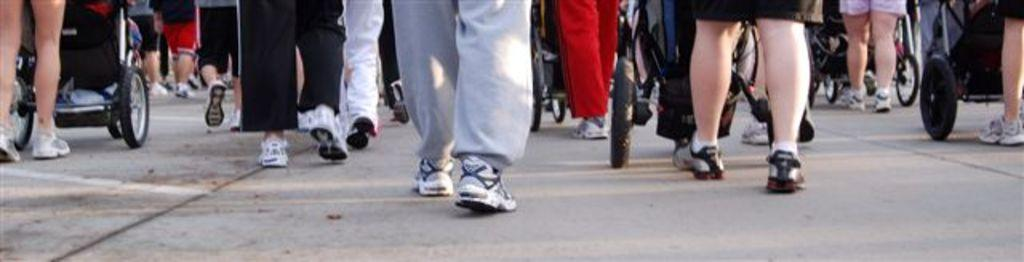What is happening with the group of people in the image? The people are walking in the image. What else can be seen in the image besides the group of people? There are vehicles on the road in the image. Reasoning: Let' Let's think step by step in order to produce the conversation. We start by identifying the main subject in the image, which is the group of people. Then, we describe their actions, which are walking. Finally, we expand the conversation to include other elements in the image, such as the vehicles on the road. Each question is designed to elicit a specific detail about the image that is known from the provided facts. Absurd Question/Answer: What type of sign can be seen on the bed in the image? There is no bed or sign present in the image. 